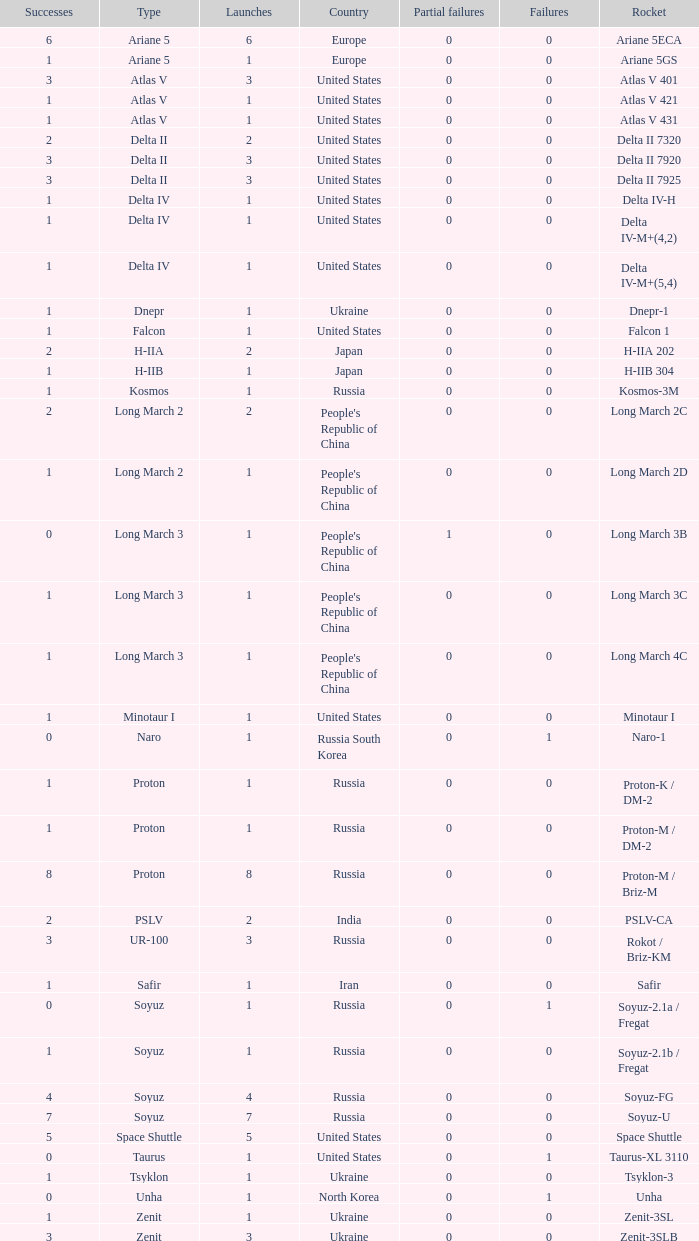What's the total failures among rockets that had more than 3 successes, type ariane 5 and more than 0 partial failures? 0.0. 